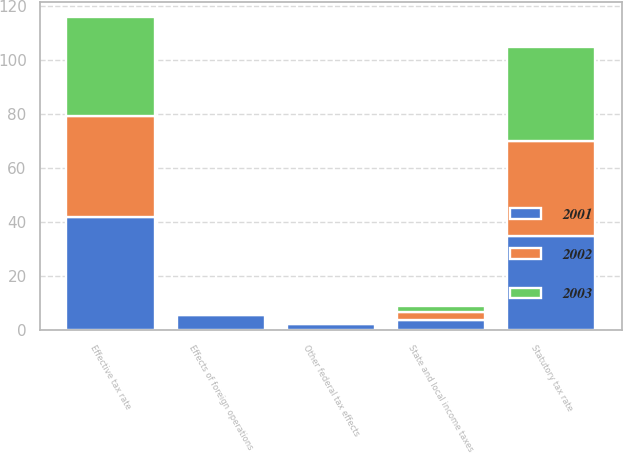Convert chart. <chart><loc_0><loc_0><loc_500><loc_500><stacked_bar_chart><ecel><fcel>Statutory tax rate<fcel>Effects of foreign operations<fcel>State and local income taxes<fcel>Other federal tax effects<fcel>Effective tax rate<nl><fcel>2003<fcel>35<fcel>0.4<fcel>2.2<fcel>0.2<fcel>36.6<nl><fcel>2001<fcel>35<fcel>5.6<fcel>3.9<fcel>2.4<fcel>42.1<nl><fcel>2002<fcel>35<fcel>0.7<fcel>3<fcel>0.2<fcel>37.1<nl></chart> 